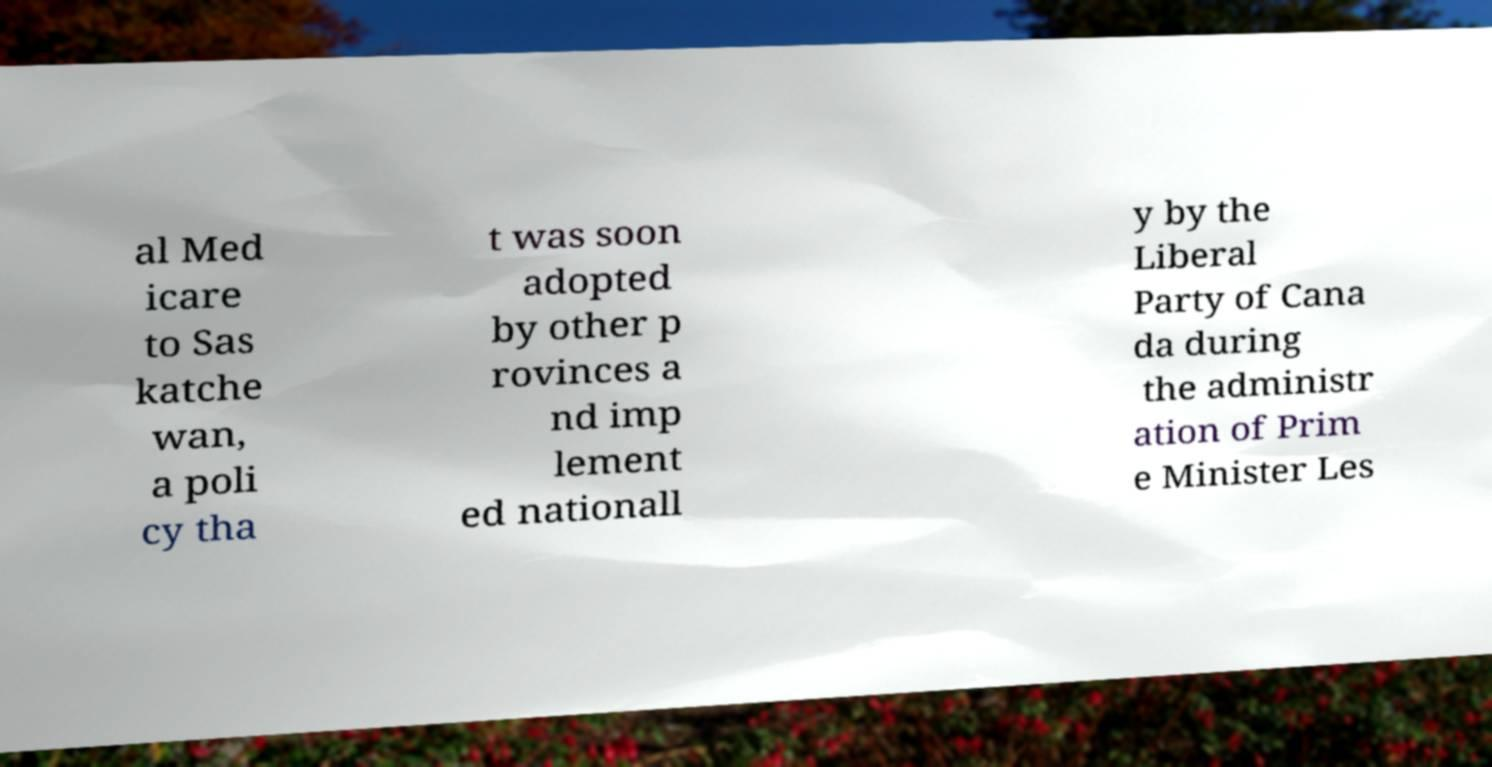Can you read and provide the text displayed in the image?This photo seems to have some interesting text. Can you extract and type it out for me? al Med icare to Sas katche wan, a poli cy tha t was soon adopted by other p rovinces a nd imp lement ed nationall y by the Liberal Party of Cana da during the administr ation of Prim e Minister Les 